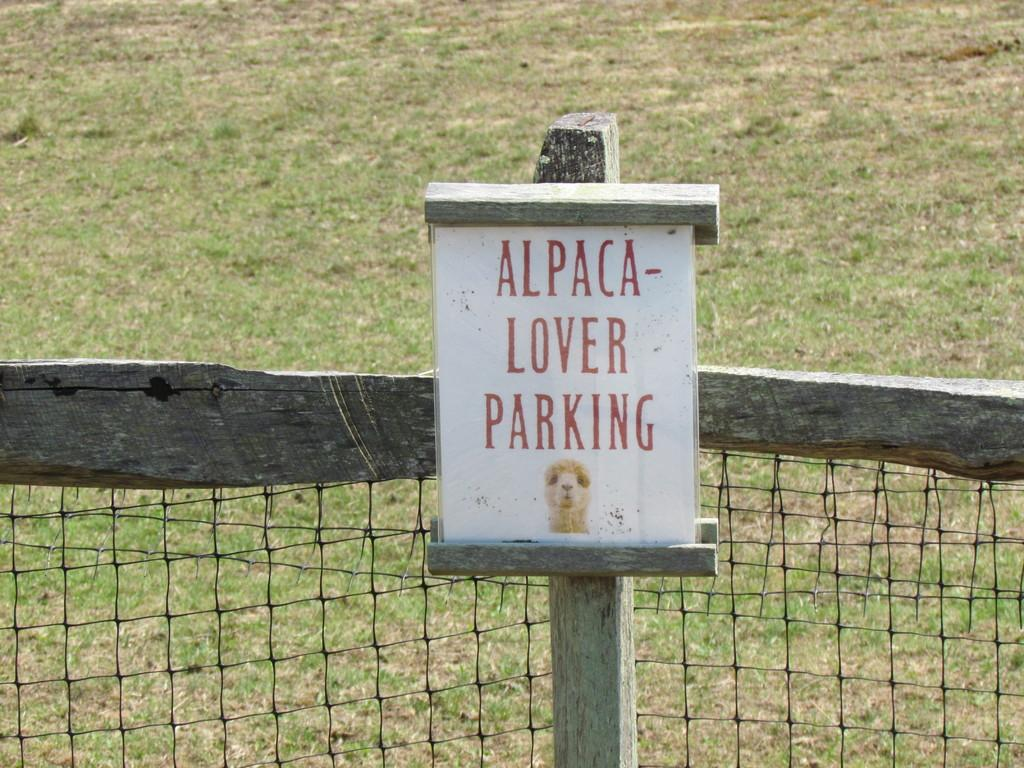What is attached to the wooden pole in the image? There is a board attached to a wooden pole in the image. What type of barrier can be seen in the image? There is net fencing in the image. What type of ground is visible in the image? There is grass visible in the image. What type of furniture is present in the image? There is no furniture present in the image. What time of day is depicted in the image? The time of day cannot be determined from the image, as there are no clues or indicators present. 